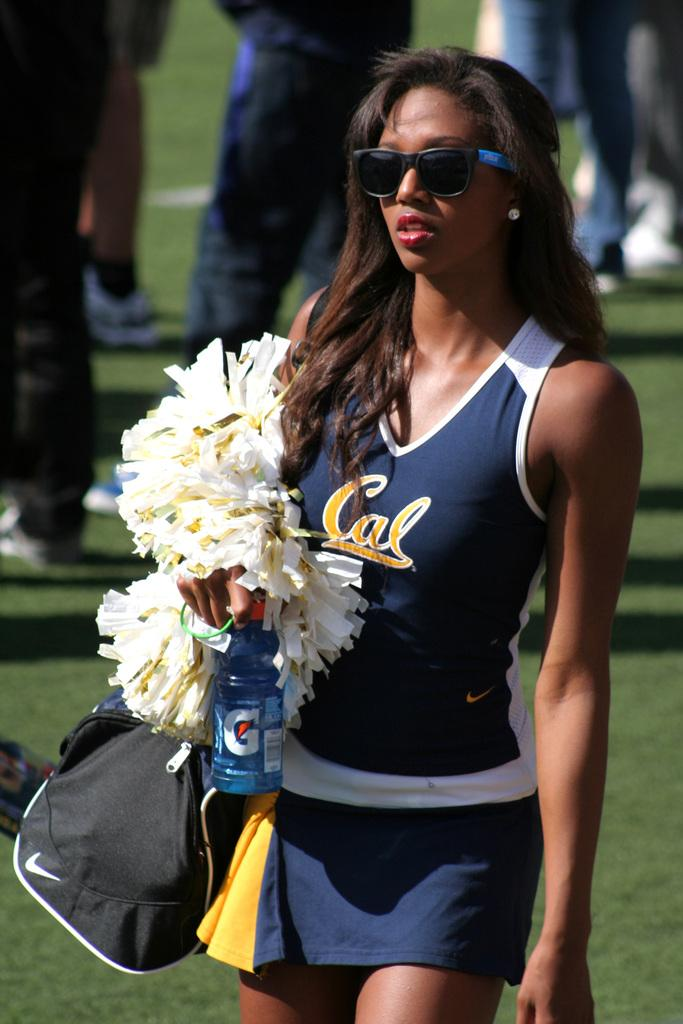<image>
Summarize the visual content of the image. A woman in a blue and white uniform is holdinga gatorade branded drink and has teh cal logo on her top. 